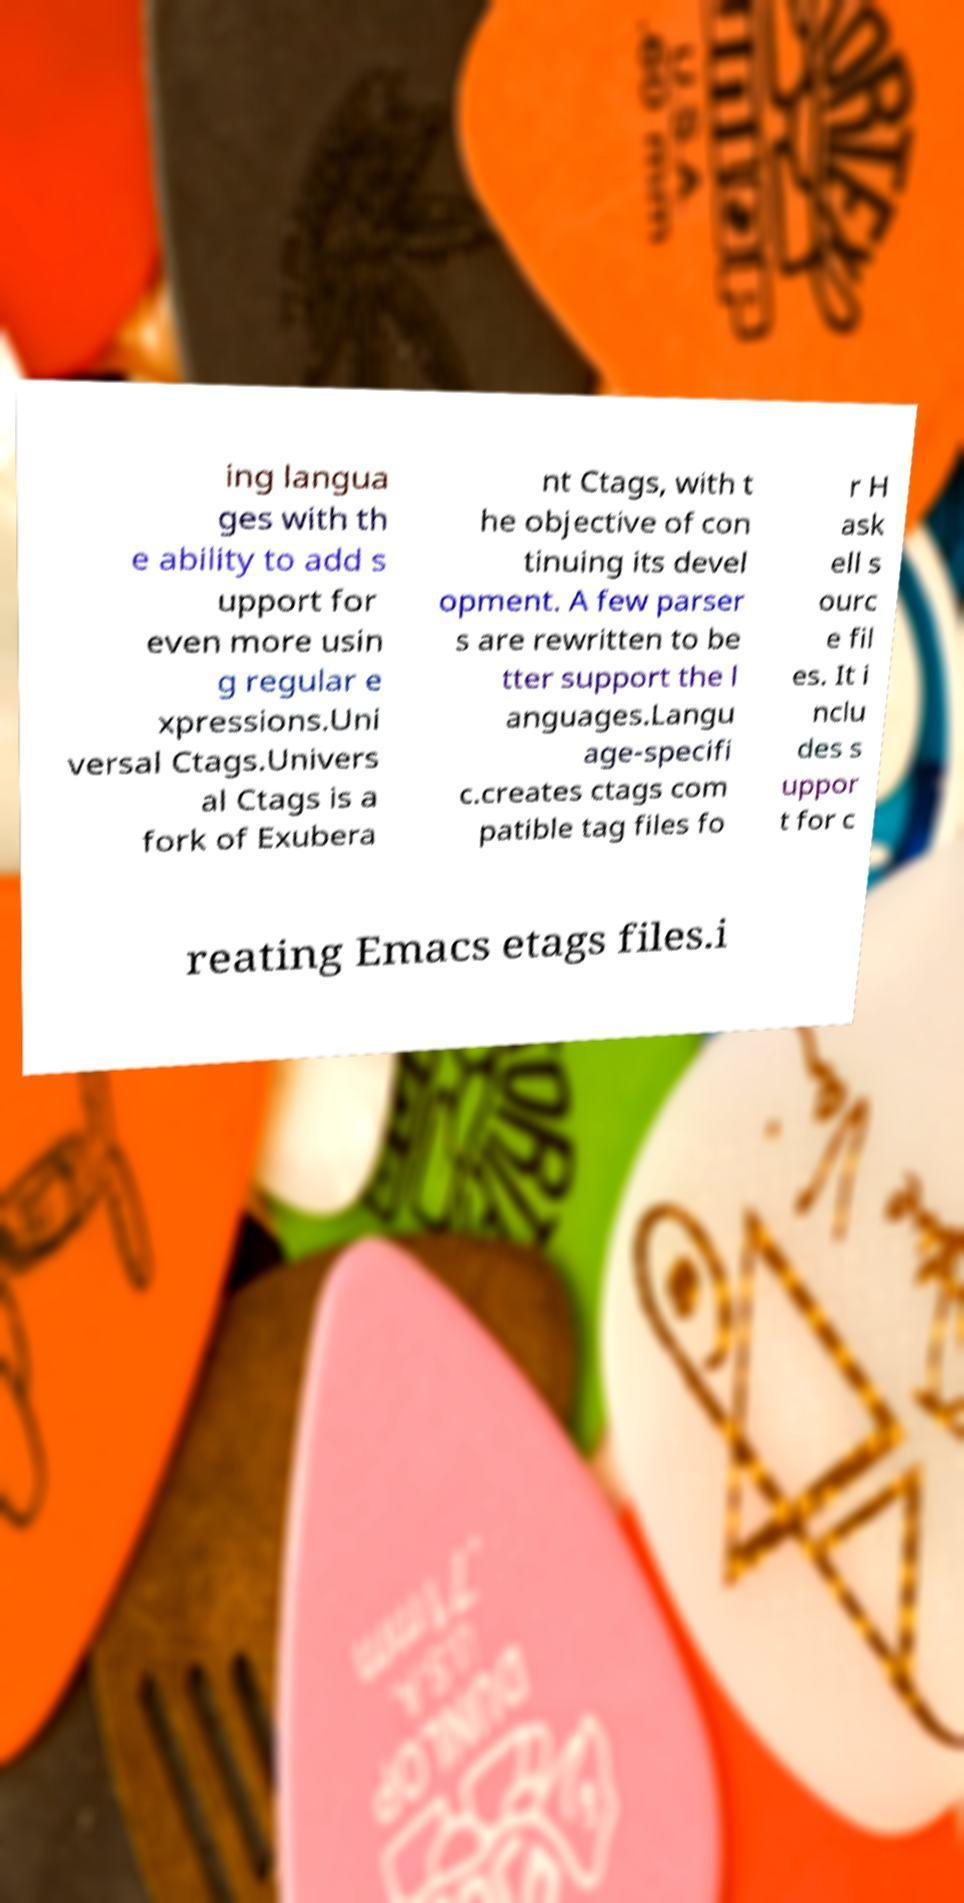Please read and relay the text visible in this image. What does it say? ing langua ges with th e ability to add s upport for even more usin g regular e xpressions.Uni versal Ctags.Univers al Ctags is a fork of Exubera nt Ctags, with t he objective of con tinuing its devel opment. A few parser s are rewritten to be tter support the l anguages.Langu age-specifi c.creates ctags com patible tag files fo r H ask ell s ourc e fil es. It i nclu des s uppor t for c reating Emacs etags files.i 